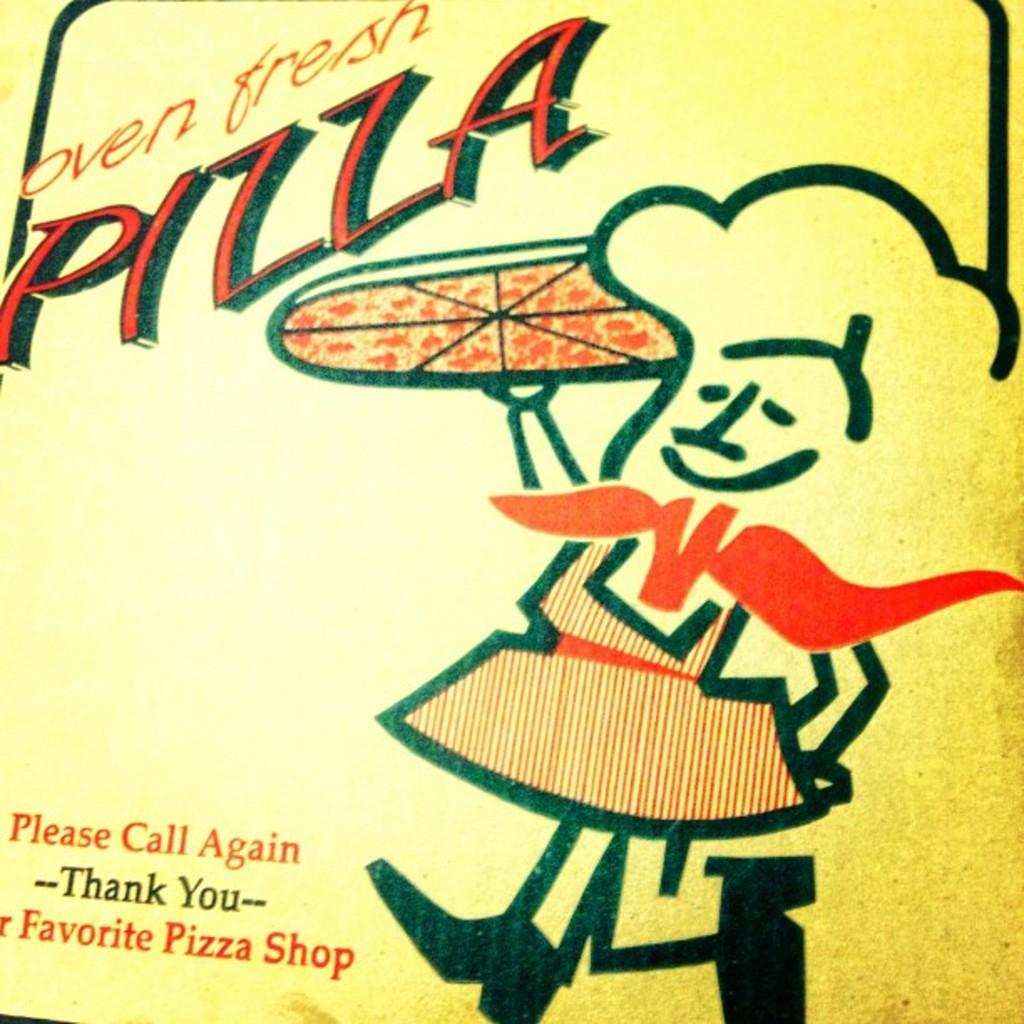<image>
Render a clear and concise summary of the photo. The box from a pizza shop describes its pizza as being oven fresh. 